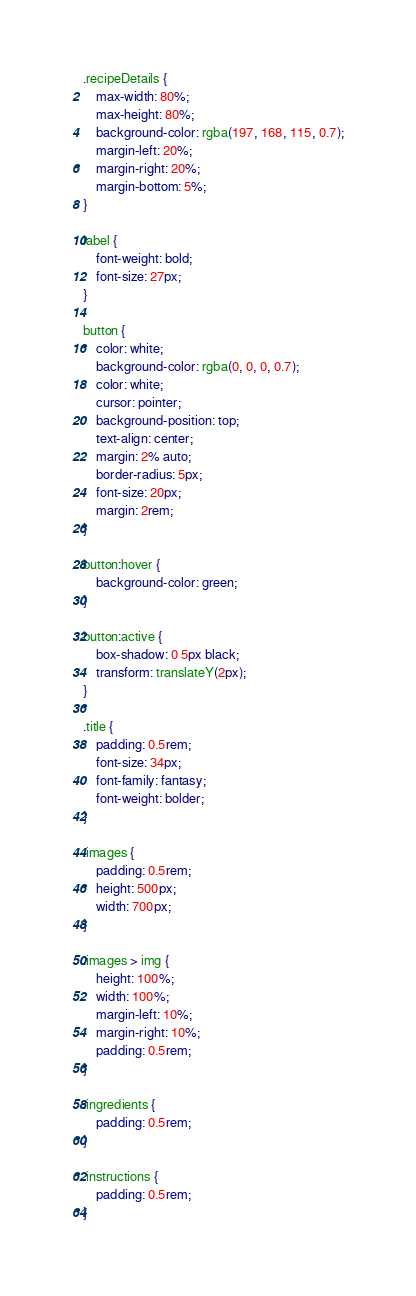<code> <loc_0><loc_0><loc_500><loc_500><_CSS_>.recipeDetails {
    max-width: 80%;
    max-height: 80%;
    background-color: rgba(197, 168, 115, 0.7);
    margin-left: 20%;
    margin-right: 20%;
    margin-bottom: 5%;
}

label {
    font-weight: bold;
    font-size: 27px;
}

button {
    color: white;
    background-color: rgba(0, 0, 0, 0.7);
    color: white;
    cursor: pointer;
    background-position: top;
    text-align: center;
    margin: 2% auto;
    border-radius: 5px;
    font-size: 20px;
    margin: 2rem;
}

button:hover {
    background-color: green;
}

button:active {
    box-shadow: 0 5px black;
    transform: translateY(2px);
}

.title {
    padding: 0.5rem;
    font-size: 34px;
    font-family: fantasy;
    font-weight: bolder;
}

.images {
    padding: 0.5rem;
    height: 500px;
    width: 700px;
}

.images > img {
    height: 100%;
    width: 100%;
    margin-left: 10%;
    margin-right: 10%;
    padding: 0.5rem;
}

.ingredients {
    padding: 0.5rem;
}

.instructions {
    padding: 0.5rem;
}
</code> 